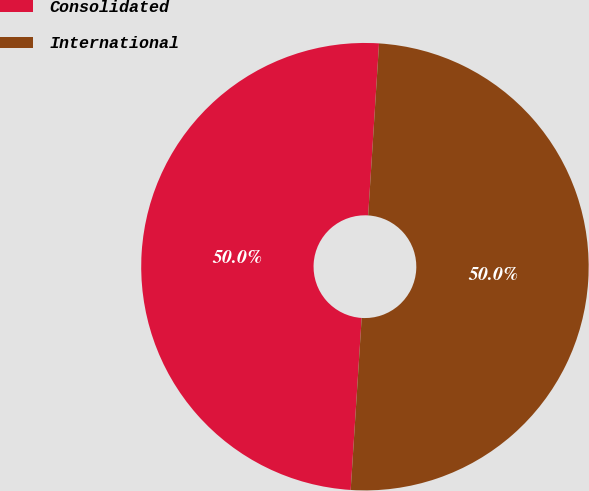Convert chart. <chart><loc_0><loc_0><loc_500><loc_500><pie_chart><fcel>Consolidated<fcel>International<nl><fcel>49.99%<fcel>50.01%<nl></chart> 